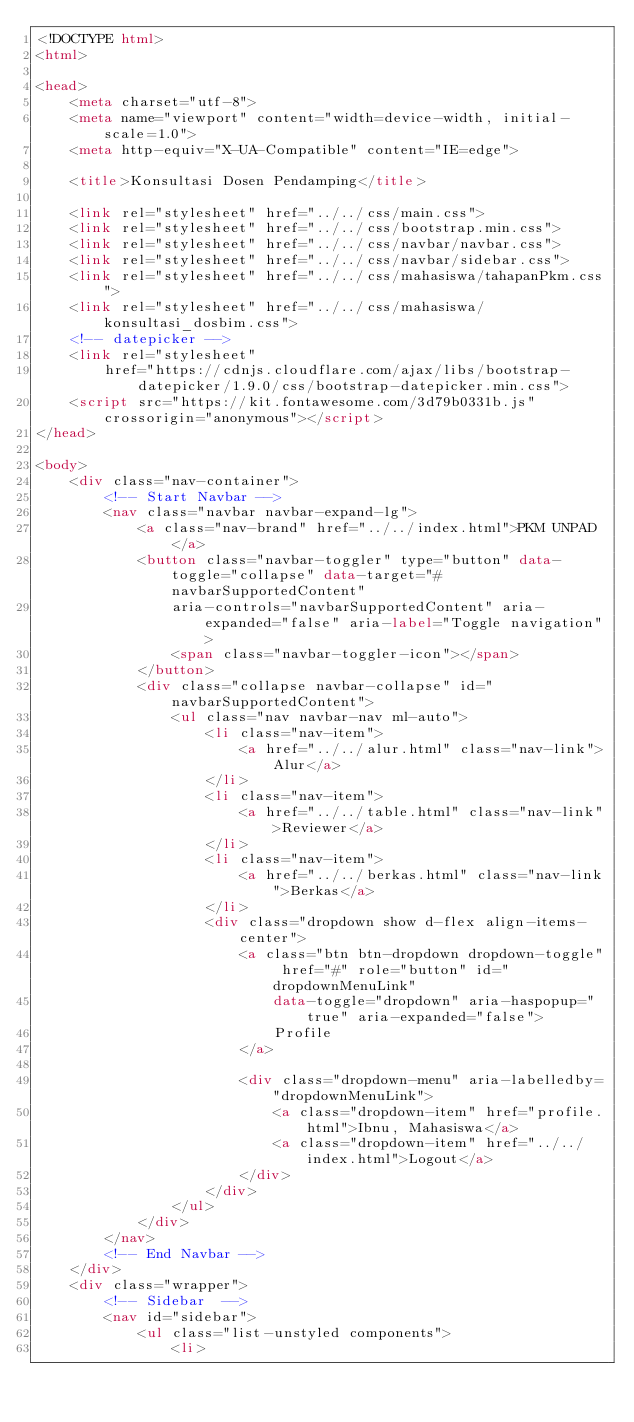Convert code to text. <code><loc_0><loc_0><loc_500><loc_500><_HTML_><!DOCTYPE html>
<html>

<head>
    <meta charset="utf-8">
    <meta name="viewport" content="width=device-width, initial-scale=1.0">
    <meta http-equiv="X-UA-Compatible" content="IE=edge">

    <title>Konsultasi Dosen Pendamping</title>

    <link rel="stylesheet" href="../../css/main.css">
    <link rel="stylesheet" href="../../css/bootstrap.min.css">
    <link rel="stylesheet" href="../../css/navbar/navbar.css">
    <link rel="stylesheet" href="../../css/navbar/sidebar.css">
    <link rel="stylesheet" href="../../css/mahasiswa/tahapanPkm.css">
    <link rel="stylesheet" href="../../css/mahasiswa/konsultasi_dosbim.css">
    <!-- datepicker -->
    <link rel="stylesheet"
        href="https://cdnjs.cloudflare.com/ajax/libs/bootstrap-datepicker/1.9.0/css/bootstrap-datepicker.min.css">
    <script src="https://kit.fontawesome.com/3d79b0331b.js" crossorigin="anonymous"></script>
</head>

<body>
    <div class="nav-container">
        <!-- Start Navbar -->
        <nav class="navbar navbar-expand-lg">
            <a class="nav-brand" href="../../index.html">PKM UNPAD</a>
            <button class="navbar-toggler" type="button" data-toggle="collapse" data-target="#navbarSupportedContent"
                aria-controls="navbarSupportedContent" aria-expanded="false" aria-label="Toggle navigation">
                <span class="navbar-toggler-icon"></span>
            </button>
            <div class="collapse navbar-collapse" id="navbarSupportedContent">
                <ul class="nav navbar-nav ml-auto">
                    <li class="nav-item">
                        <a href="../../alur.html" class="nav-link">Alur</a>
                    </li>
                    <li class="nav-item">
                        <a href="../../table.html" class="nav-link">Reviewer</a>
                    </li>
                    <li class="nav-item">
                        <a href="../../berkas.html" class="nav-link">Berkas</a>
                    </li>
                    <div class="dropdown show d-flex align-items-center">
                        <a class="btn btn-dropdown dropdown-toggle" href="#" role="button" id="dropdownMenuLink"
                            data-toggle="dropdown" aria-haspopup="true" aria-expanded="false">
                            Profile
                        </a>

                        <div class="dropdown-menu" aria-labelledby="dropdownMenuLink">
                            <a class="dropdown-item" href="profile.html">Ibnu, Mahasiswa</a>
                            <a class="dropdown-item" href="../../index.html">Logout</a>
                        </div>
                    </div>
                </ul>
            </div>
        </nav>
        <!-- End Navbar -->
    </div>
    <div class="wrapper">
        <!-- Sidebar  -->
        <nav id="sidebar">
            <ul class="list-unstyled components">
                <li></code> 